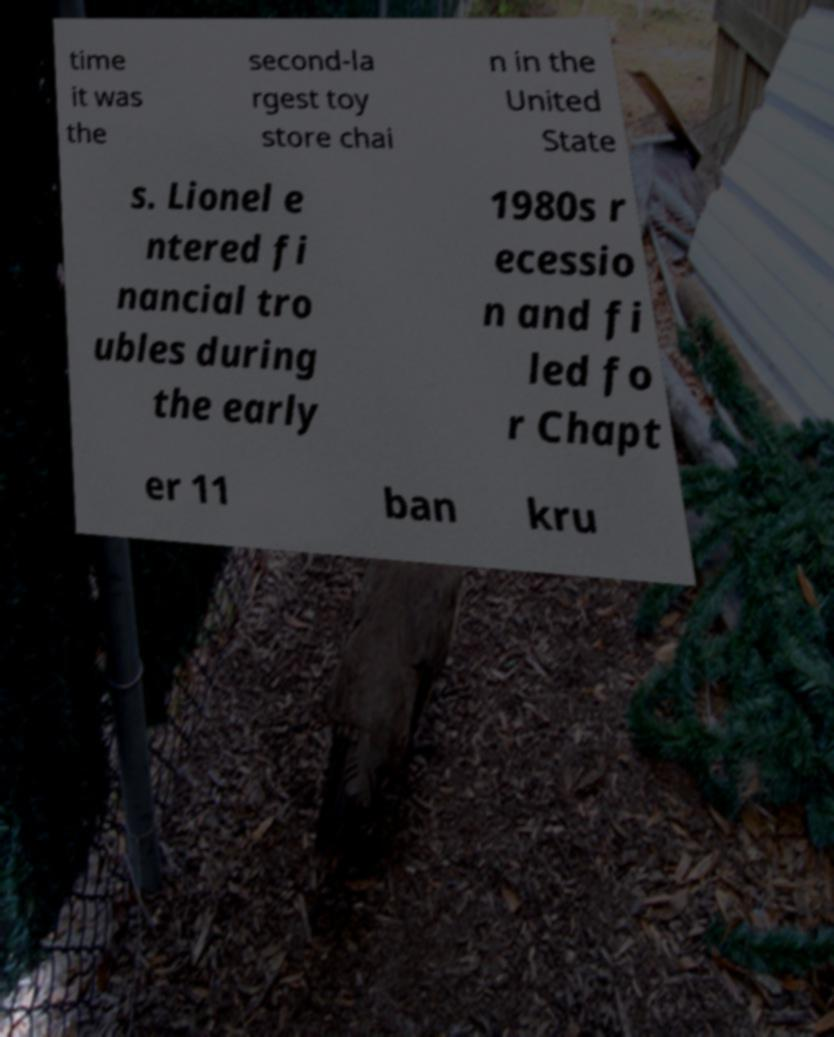Can you read and provide the text displayed in the image?This photo seems to have some interesting text. Can you extract and type it out for me? time it was the second-la rgest toy store chai n in the United State s. Lionel e ntered fi nancial tro ubles during the early 1980s r ecessio n and fi led fo r Chapt er 11 ban kru 